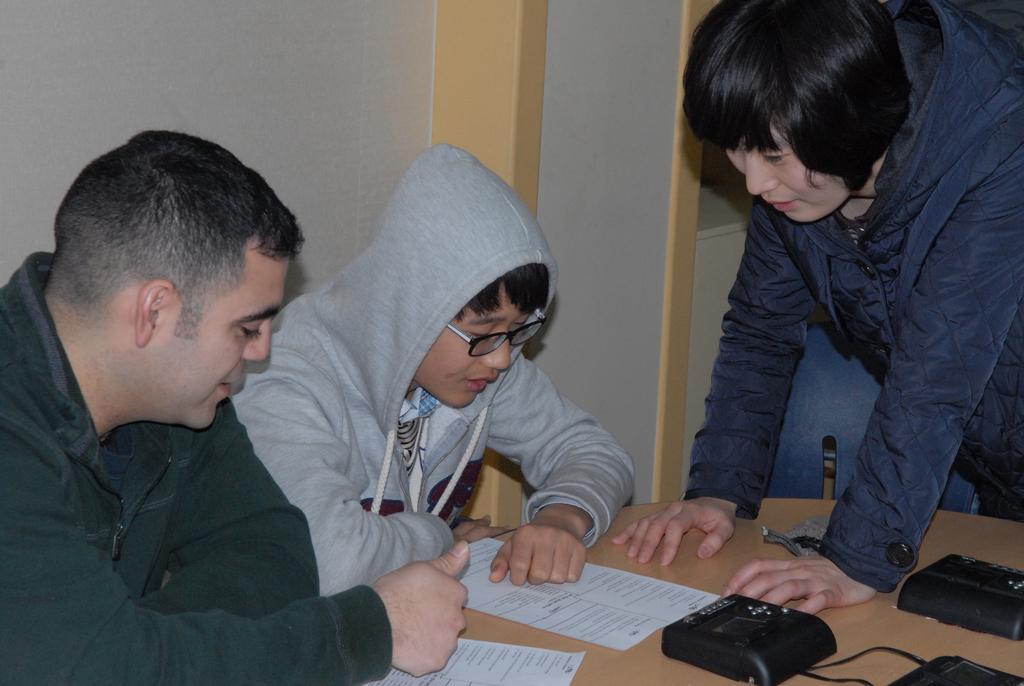How would you summarize this image in a sentence or two? In this image there are two people sitting in chairs and a person standing and are looking at the papers in front of them on the table. On the table there are some other objects, behind them there is a chair, behind the chair there is a wall. 